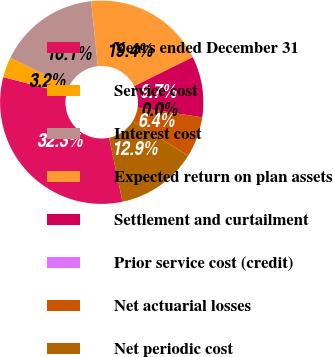Convert chart to OTSL. <chart><loc_0><loc_0><loc_500><loc_500><pie_chart><fcel>Years ended December 31<fcel>Service cost<fcel>Interest cost<fcel>Expected return on plan assets<fcel>Settlement and curtailment<fcel>Prior service cost (credit)<fcel>Net actuarial losses<fcel>Net periodic cost<nl><fcel>32.26%<fcel>3.23%<fcel>16.13%<fcel>19.35%<fcel>9.68%<fcel>0.0%<fcel>6.45%<fcel>12.9%<nl></chart> 